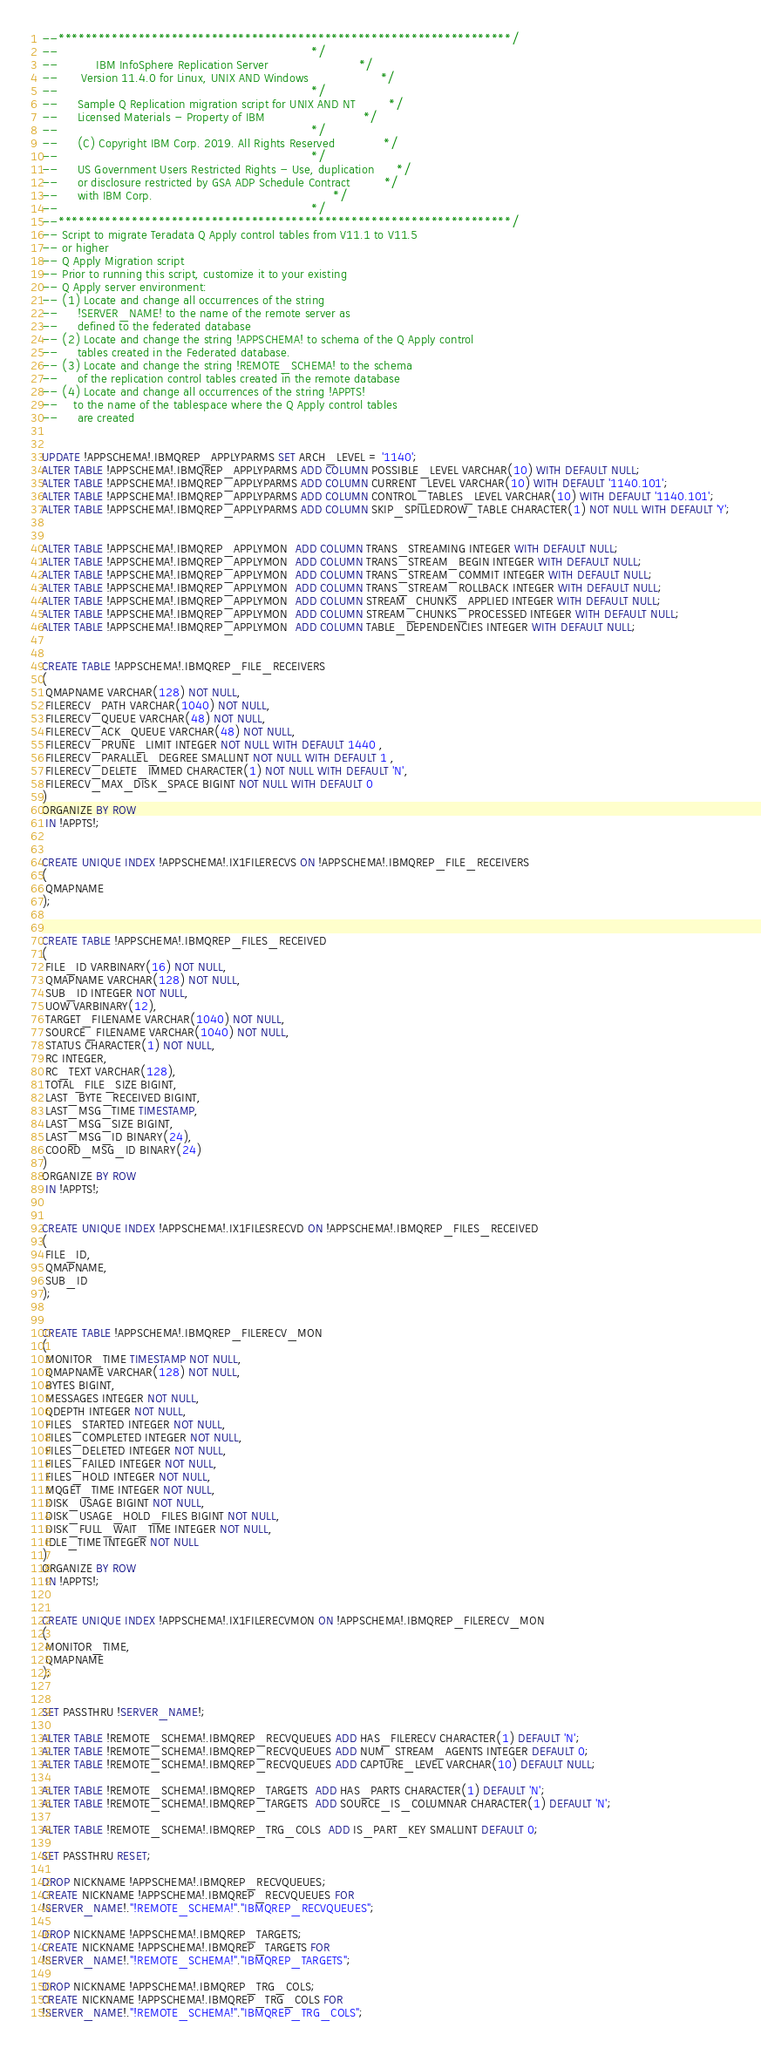Convert code to text. <code><loc_0><loc_0><loc_500><loc_500><_SQL_>--********************************************************************/
--                                                                   */
--          IBM InfoSphere Replication Server                        */
--      Version 11.4.0 for Linux, UNIX AND Windows                   */
--                                                                   */
--     Sample Q Replication migration script for UNIX AND NT         */
--     Licensed Materials - Property of IBM                          */
--                                                                   */
--     (C) Copyright IBM Corp. 2019. All Rights Reserved             */
--                                                                   */
--     US Government Users Restricted Rights - Use, duplication      */
--     or disclosure restricted by GSA ADP Schedule Contract         */
--     with IBM Corp.                                                */
--                                                                   */
--********************************************************************/
-- Script to migrate Teradata Q Apply control tables from V11.1 to V11.5 
-- or higher
-- Q Apply Migration script 
-- Prior to running this script, customize it to your existing 
-- Q Apply server environment:
-- (1) Locate and change all occurrences of the string 
--     !SERVER_NAME! to the name of the remote server as
--     defined to the federated database
-- (2) Locate and change the string !APPSCHEMA! to schema of the Q Apply control
--     tables created in the Federated database.
-- (3) Locate and change the string !REMOTE_SCHEMA! to the schema
--     of the replication control tables created in the remote database
-- (4) Locate and change all occurrences of the string !APPTS!
--    to the name of the tablespace where the Q Apply control tables 
--     are created


UPDATE !APPSCHEMA!.IBMQREP_APPLYPARMS SET ARCH_LEVEL = '1140';
ALTER TABLE !APPSCHEMA!.IBMQREP_APPLYPARMS ADD COLUMN POSSIBLE_LEVEL VARCHAR(10) WITH DEFAULT NULL;
ALTER TABLE !APPSCHEMA!.IBMQREP_APPLYPARMS ADD COLUMN CURRENT_LEVEL VARCHAR(10) WITH DEFAULT '1140.101';
ALTER TABLE !APPSCHEMA!.IBMQREP_APPLYPARMS ADD COLUMN CONTROL_TABLES_LEVEL VARCHAR(10) WITH DEFAULT '1140.101';
ALTER TABLE !APPSCHEMA!.IBMQREP_APPLYPARMS ADD COLUMN SKIP_SPILLEDROW_TABLE CHARACTER(1) NOT NULL WITH DEFAULT 'Y';


ALTER TABLE !APPSCHEMA!.IBMQREP_APPLYMON  ADD COLUMN TRANS_STREAMING INTEGER WITH DEFAULT NULL;
ALTER TABLE !APPSCHEMA!.IBMQREP_APPLYMON  ADD COLUMN TRANS_STREAM_BEGIN INTEGER WITH DEFAULT NULL;
ALTER TABLE !APPSCHEMA!.IBMQREP_APPLYMON  ADD COLUMN TRANS_STREAM_COMMIT INTEGER WITH DEFAULT NULL;
ALTER TABLE !APPSCHEMA!.IBMQREP_APPLYMON  ADD COLUMN TRANS_STREAM_ROLLBACK INTEGER WITH DEFAULT NULL;
ALTER TABLE !APPSCHEMA!.IBMQREP_APPLYMON  ADD COLUMN STREAM_CHUNKS_APPLIED INTEGER WITH DEFAULT NULL;
ALTER TABLE !APPSCHEMA!.IBMQREP_APPLYMON  ADD COLUMN STREAM_CHUNKS_PROCESSED INTEGER WITH DEFAULT NULL;
ALTER TABLE !APPSCHEMA!.IBMQREP_APPLYMON  ADD COLUMN TABLE_DEPENDENCIES INTEGER WITH DEFAULT NULL;


CREATE TABLE !APPSCHEMA!.IBMQREP_FILE_RECEIVERS
(
 QMAPNAME VARCHAR(128) NOT NULL,
 FILERECV_PATH VARCHAR(1040) NOT NULL,
 FILERECV_QUEUE VARCHAR(48) NOT NULL,
 FILERECV_ACK_QUEUE VARCHAR(48) NOT NULL,
 FILERECV_PRUNE_LIMIT INTEGER NOT NULL WITH DEFAULT 1440 ,
 FILERECV_PARALLEL_DEGREE SMALLINT NOT NULL WITH DEFAULT 1 ,
 FILERECV_DELETE_IMMED CHARACTER(1) NOT NULL WITH DEFAULT 'N',
 FILERECV_MAX_DISK_SPACE BIGINT NOT NULL WITH DEFAULT 0
)
ORGANIZE BY ROW
 IN !APPTS!;


CREATE UNIQUE INDEX !APPSCHEMA!.IX1FILERECVS ON !APPSCHEMA!.IBMQREP_FILE_RECEIVERS
(
 QMAPNAME
);


CREATE TABLE !APPSCHEMA!.IBMQREP_FILES_RECEIVED
(
 FILE_ID VARBINARY(16) NOT NULL,
 QMAPNAME VARCHAR(128) NOT NULL,
 SUB_ID INTEGER NOT NULL,
 UOW VARBINARY(12),
 TARGET_FILENAME VARCHAR(1040) NOT NULL,
 SOURCE_FILENAME VARCHAR(1040) NOT NULL,
 STATUS CHARACTER(1) NOT NULL,
 RC INTEGER,
 RC_TEXT VARCHAR(128),
 TOTAL_FILE_SIZE BIGINT,
 LAST_BYTE_RECEIVED BIGINT,
 LAST_MSG_TIME TIMESTAMP,
 LAST_MSG_SIZE BIGINT,
 LAST_MSG_ID BINARY(24),
 COORD_MSG_ID BINARY(24)
)
ORGANIZE BY ROW
 IN !APPTS!;


CREATE UNIQUE INDEX !APPSCHEMA!.IX1FILESRECVD ON !APPSCHEMA!.IBMQREP_FILES_RECEIVED
(
 FILE_ID,
 QMAPNAME,
 SUB_ID
);


CREATE TABLE !APPSCHEMA!.IBMQREP_FILERECV_MON
(
 MONITOR_TIME TIMESTAMP NOT NULL,
 QMAPNAME VARCHAR(128) NOT NULL,
 BYTES BIGINT,
 MESSAGES INTEGER NOT NULL,
 QDEPTH INTEGER NOT NULL,
 FILES_STARTED INTEGER NOT NULL,
 FILES_COMPLETED INTEGER NOT NULL,
 FILES_DELETED INTEGER NOT NULL,
 FILES_FAILED INTEGER NOT NULL,
 FILES_HOLD INTEGER NOT NULL,
 MQGET_TIME INTEGER NOT NULL,
 DISK_USAGE BIGINT NOT NULL,
 DISK_USAGE_HOLD_FILES BIGINT NOT NULL,
 DISK_FULL_WAIT_TIME INTEGER NOT NULL,
 IDLE_TIME INTEGER NOT NULL
)
ORGANIZE BY ROW
 IN !APPTS!;


CREATE UNIQUE INDEX !APPSCHEMA!.IX1FILERECVMON ON !APPSCHEMA!.IBMQREP_FILERECV_MON
(
 MONITOR_TIME,
 QMAPNAME
);


SET PASSTHRU !SERVER_NAME!;

ALTER TABLE !REMOTE_SCHEMA!.IBMQREP_RECVQUEUES ADD HAS_FILERECV CHARACTER(1) DEFAULT 'N';
ALTER TABLE !REMOTE_SCHEMA!.IBMQREP_RECVQUEUES ADD NUM_STREAM_AGENTS INTEGER DEFAULT 0;
ALTER TABLE !REMOTE_SCHEMA!.IBMQREP_RECVQUEUES ADD CAPTURE_LEVEL VARCHAR(10) DEFAULT NULL;

ALTER TABLE !REMOTE_SCHEMA!.IBMQREP_TARGETS  ADD HAS_PARTS CHARACTER(1) DEFAULT 'N';
ALTER TABLE !REMOTE_SCHEMA!.IBMQREP_TARGETS  ADD SOURCE_IS_COLUMNAR CHARACTER(1) DEFAULT 'N';

ALTER TABLE !REMOTE_SCHEMA!.IBMQREP_TRG_COLS  ADD IS_PART_KEY SMALLINT DEFAULT 0;

SET PASSTHRU RESET;

DROP NICKNAME !APPSCHEMA!.IBMQREP_RECVQUEUES;
CREATE NICKNAME !APPSCHEMA!.IBMQREP_RECVQUEUES FOR
!SERVER_NAME!."!REMOTE_SCHEMA!"."IBMQREP_RECVQUEUES";

DROP NICKNAME !APPSCHEMA!.IBMQREP_TARGETS;
CREATE NICKNAME !APPSCHEMA!.IBMQREP_TARGETS FOR
!SERVER_NAME!."!REMOTE_SCHEMA!"."IBMQREP_TARGETS";

DROP NICKNAME !APPSCHEMA!.IBMQREP_TRG_COLS;
CREATE NICKNAME !APPSCHEMA!.IBMQREP_TRG_COLS FOR
!SERVER_NAME!."!REMOTE_SCHEMA!"."IBMQREP_TRG_COLS";

</code> 